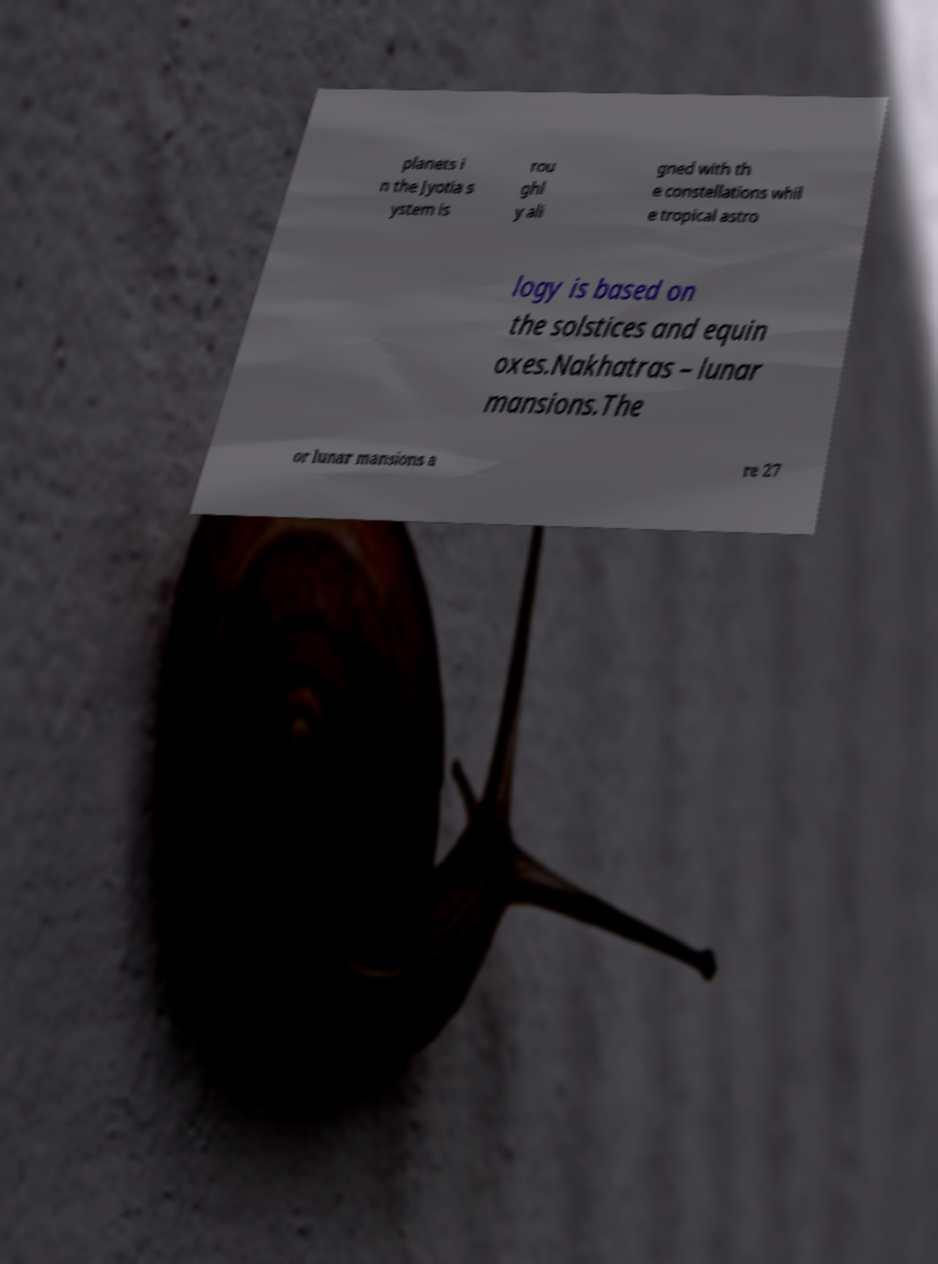Could you assist in decoding the text presented in this image and type it out clearly? planets i n the Jyotia s ystem is rou ghl y ali gned with th e constellations whil e tropical astro logy is based on the solstices and equin oxes.Nakhatras – lunar mansions.The or lunar mansions a re 27 